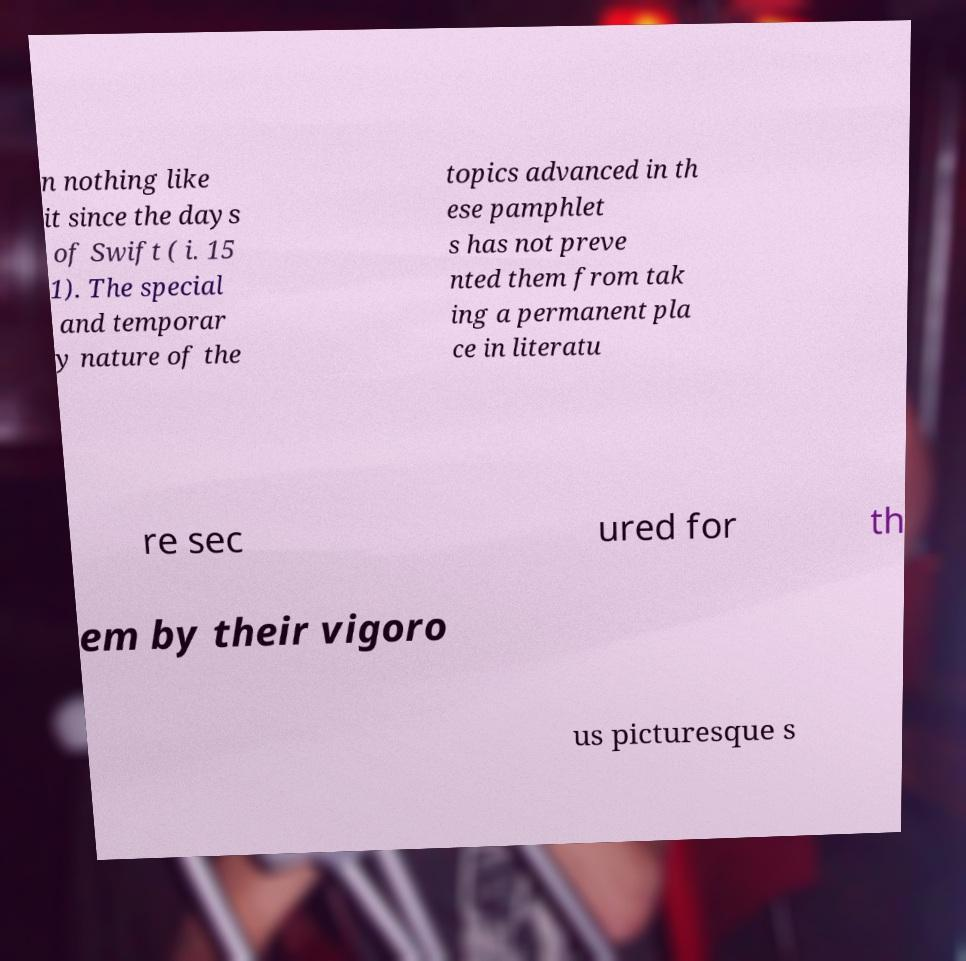Could you extract and type out the text from this image? n nothing like it since the days of Swift ( i. 15 1). The special and temporar y nature of the topics advanced in th ese pamphlet s has not preve nted them from tak ing a permanent pla ce in literatu re sec ured for th em by their vigoro us picturesque s 